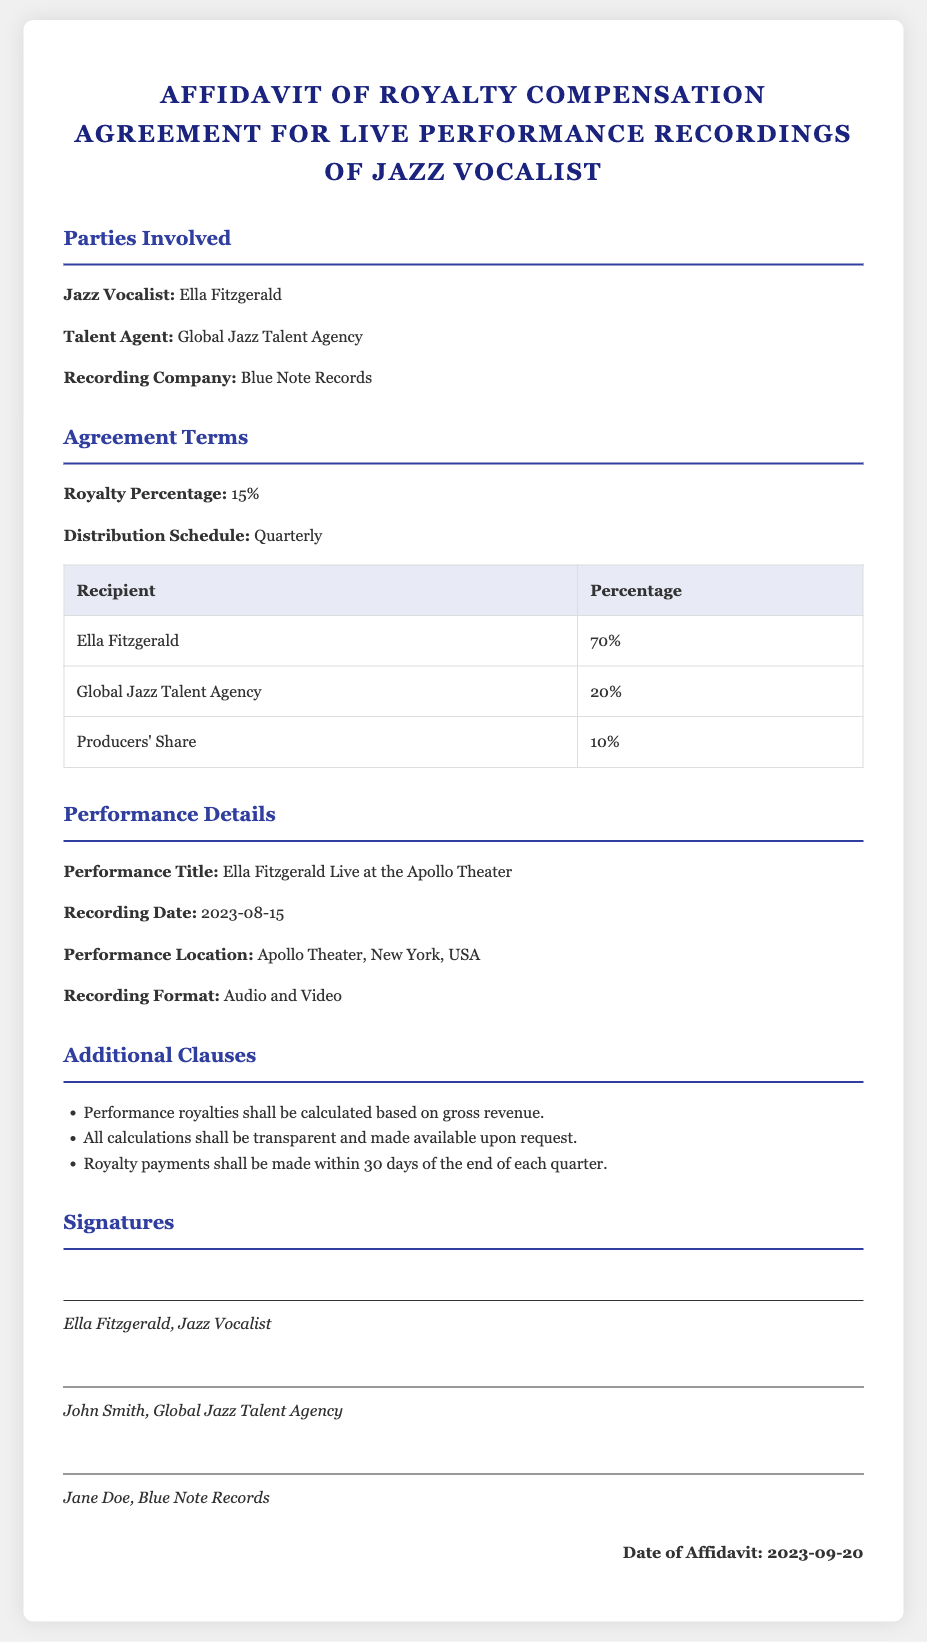What is the name of the jazz vocalist? The document specifies that the jazz vocalist is Ella Fitzgerald.
Answer: Ella Fitzgerald What percentage of royalties does Ella Fitzgerald receive? The document states that Ella Fitzgerald receives 70% of the royalties.
Answer: 70% When is the distribution schedule for the royalties? The document indicates that the distribution schedule for the royalties is quarterly.
Answer: Quarterly What is the title of the performance recorded? The performance title mentioned in the document is "Ella Fitzgerald Live at the Apollo Theater."
Answer: Ella Fitzgerald Live at the Apollo Theater Who is the recording company involved? The document lists Blue Note Records as the recording company.
Answer: Blue Note Records What is the date of the recording? The document specifies the recording date as August 15, 2023.
Answer: 2023-08-15 What is the total percentage of royalties allocated to the Global Jazz Talent Agency? The document states that the Global Jazz Talent Agency receives 20% of the royalties.
Answer: 20% How long do they have to wait for royalty payments after the end of each quarter? The document specifies that royalty payments shall be made within 30 days of the end of each quarter.
Answer: 30 days What format is the performance recording in? The document states that the recording format is audio and video.
Answer: Audio and Video 